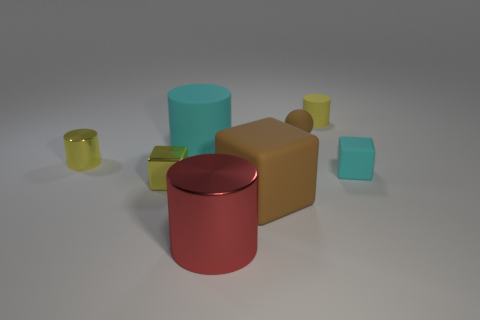Subtract all gray cylinders. Subtract all green balls. How many cylinders are left? 4 Add 2 cyan blocks. How many objects exist? 10 Subtract all cubes. How many objects are left? 5 Add 6 large blocks. How many large blocks exist? 7 Subtract 1 brown cubes. How many objects are left? 7 Subtract all big brown blocks. Subtract all red objects. How many objects are left? 6 Add 2 matte cubes. How many matte cubes are left? 4 